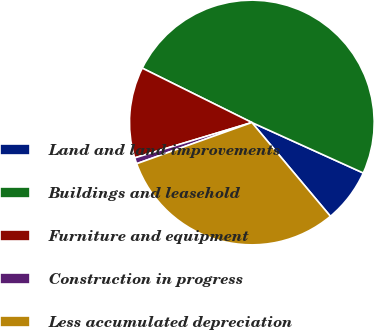Convert chart. <chart><loc_0><loc_0><loc_500><loc_500><pie_chart><fcel>Land and land improvements<fcel>Buildings and leasehold<fcel>Furniture and equipment<fcel>Construction in progress<fcel>Less accumulated depreciation<nl><fcel>7.13%<fcel>49.44%<fcel>12.0%<fcel>0.8%<fcel>30.63%<nl></chart> 